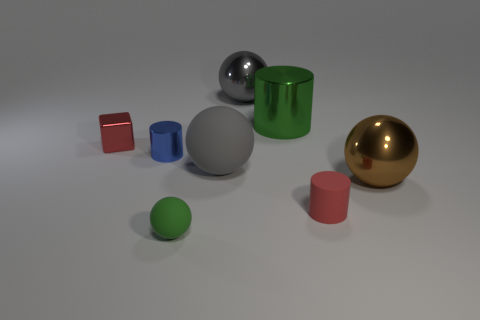Are there any other things that have the same shape as the small red metallic object?
Provide a short and direct response. No. Are any big purple cylinders visible?
Your answer should be very brief. No. There is a metallic thing that is behind the small blue cylinder and in front of the green metal object; what is its shape?
Your answer should be compact. Cube. There is a red thing that is in front of the small red metal object; how big is it?
Provide a short and direct response. Small. Does the thing that is in front of the small red matte cylinder have the same color as the big cylinder?
Offer a terse response. Yes. How many other red objects are the same shape as the small red matte thing?
Ensure brevity in your answer.  0. How many objects are either shiny objects that are in front of the cube or small objects left of the tiny green matte ball?
Offer a very short reply. 3. What number of cyan objects are blocks or large cylinders?
Give a very brief answer. 0. What is the material of the thing that is behind the blue thing and left of the gray shiny thing?
Make the answer very short. Metal. Do the small blue object and the big cylinder have the same material?
Provide a succinct answer. Yes. 